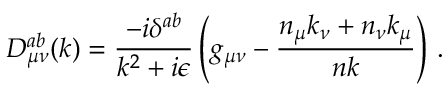<formula> <loc_0><loc_0><loc_500><loc_500>D _ { \mu \nu } ^ { a b } ( k ) = { \frac { - i \delta ^ { a b } } { k ^ { 2 } + i \epsilon } } \left ( g _ { \mu \nu } - { \frac { n _ { \mu } k _ { \nu } + n _ { \nu } k _ { \mu } } { n k } } \right ) \, .</formula> 